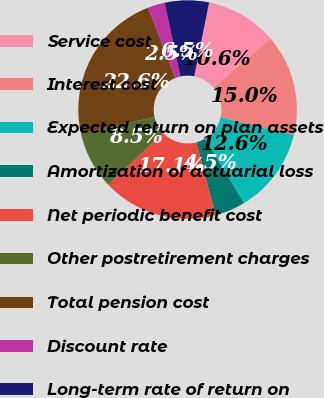Convert chart. <chart><loc_0><loc_0><loc_500><loc_500><pie_chart><fcel>Service cost<fcel>Interest cost<fcel>Expected return on plan assets<fcel>Amortization of actuarial loss<fcel>Net periodic benefit cost<fcel>Other postretirement charges<fcel>Total pension cost<fcel>Discount rate<fcel>Long-term rate of return on<nl><fcel>10.56%<fcel>15.05%<fcel>12.58%<fcel>4.52%<fcel>17.07%<fcel>8.55%<fcel>22.65%<fcel>2.5%<fcel>6.53%<nl></chart> 